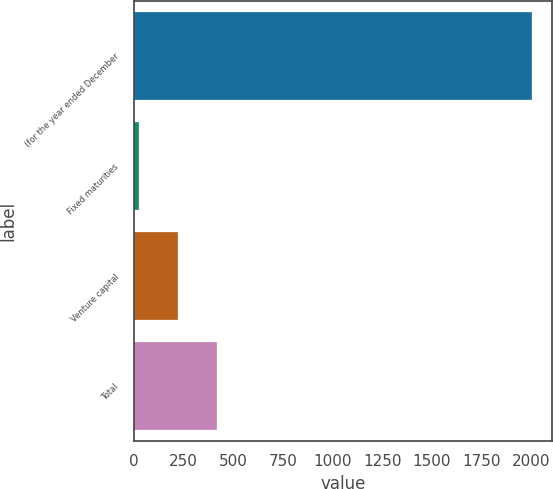Convert chart to OTSL. <chart><loc_0><loc_0><loc_500><loc_500><bar_chart><fcel>(for the year ended December<fcel>Fixed maturities<fcel>Venture capital<fcel>Total<nl><fcel>2004<fcel>25<fcel>222.9<fcel>420.8<nl></chart> 